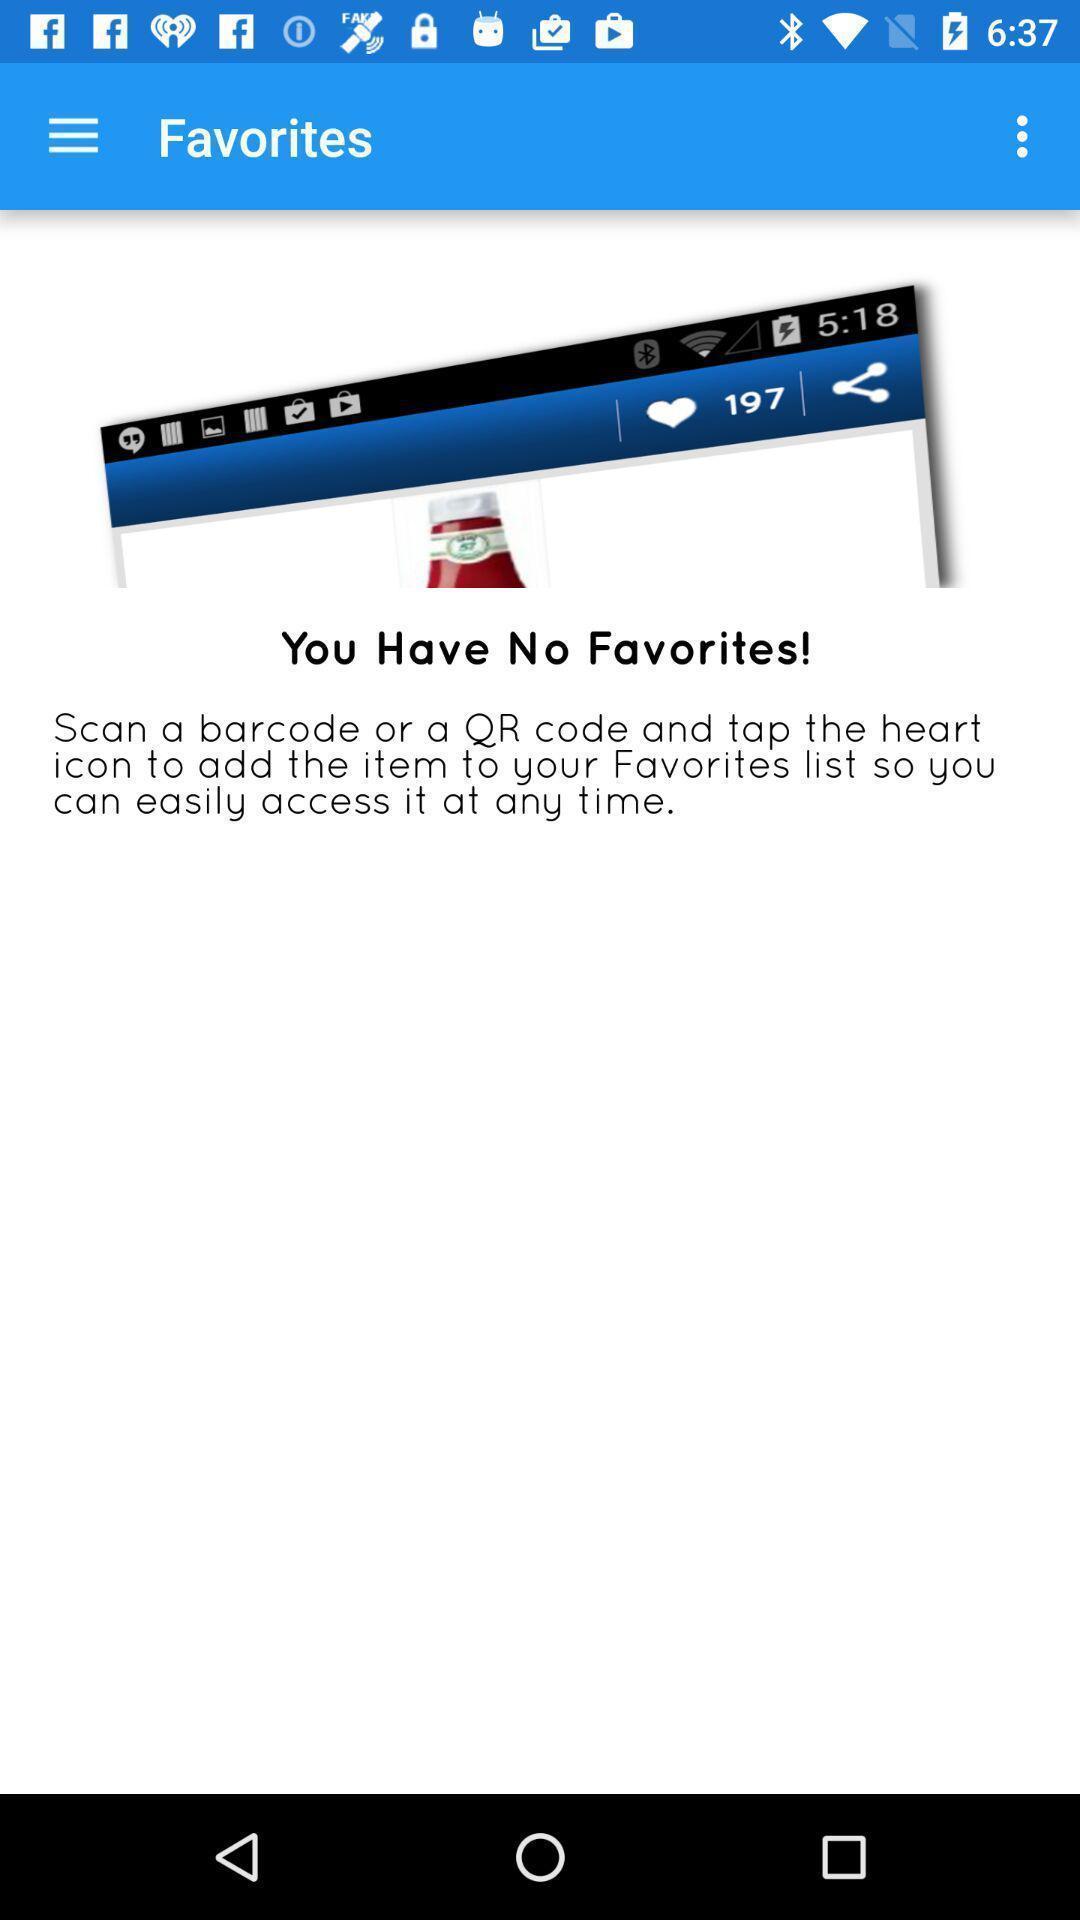What is the overall content of this screenshot? Page displaying you have no favorites. 